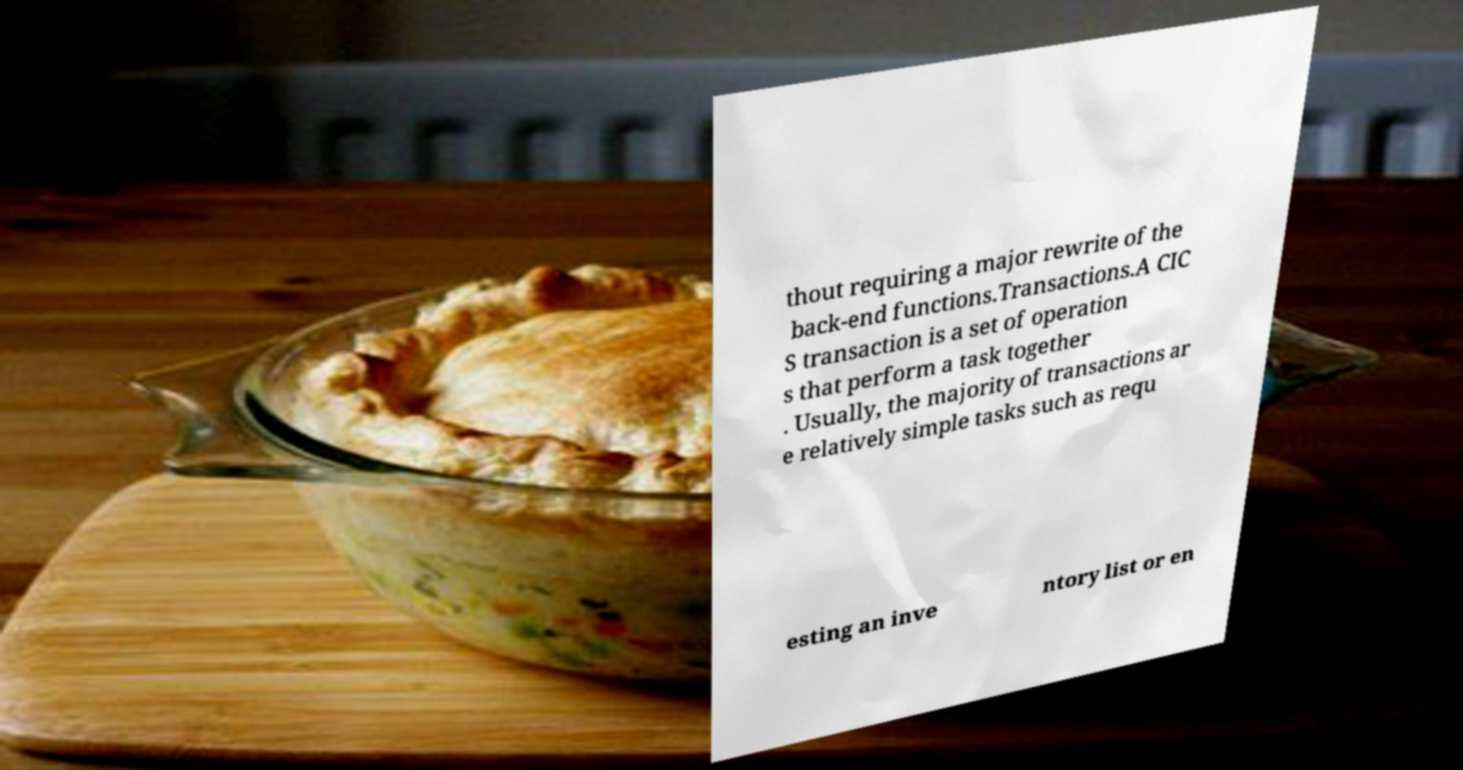Please identify and transcribe the text found in this image. thout requiring a major rewrite of the back-end functions.Transactions.A CIC S transaction is a set of operation s that perform a task together . Usually, the majority of transactions ar e relatively simple tasks such as requ esting an inve ntory list or en 